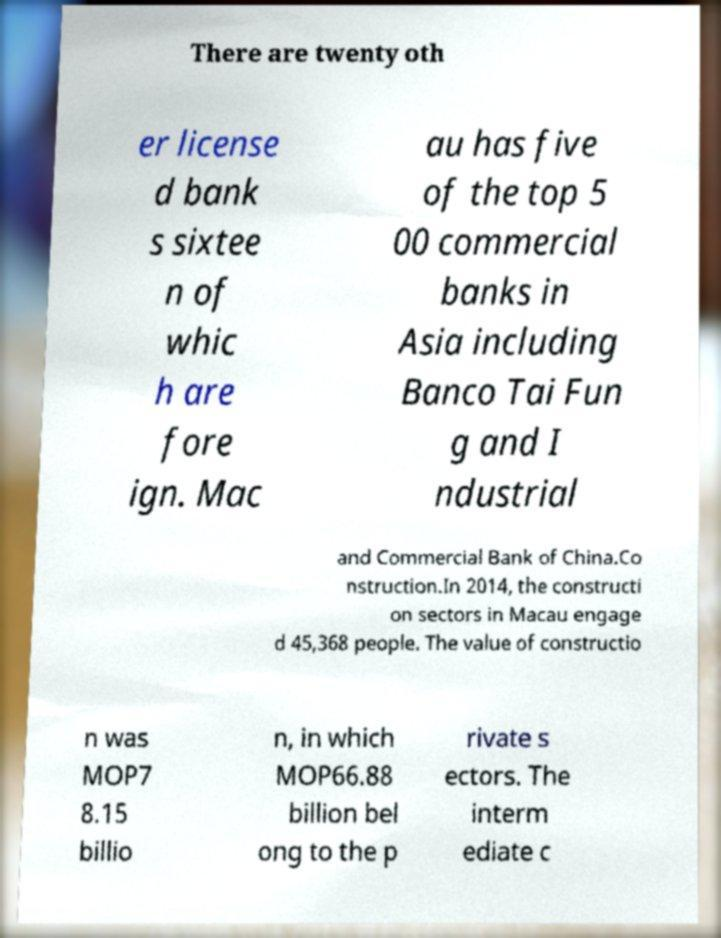What messages or text are displayed in this image? I need them in a readable, typed format. There are twenty oth er license d bank s sixtee n of whic h are fore ign. Mac au has five of the top 5 00 commercial banks in Asia including Banco Tai Fun g and I ndustrial and Commercial Bank of China.Co nstruction.In 2014, the constructi on sectors in Macau engage d 45,368 people. The value of constructio n was MOP7 8.15 billio n, in which MOP66.88 billion bel ong to the p rivate s ectors. The interm ediate c 